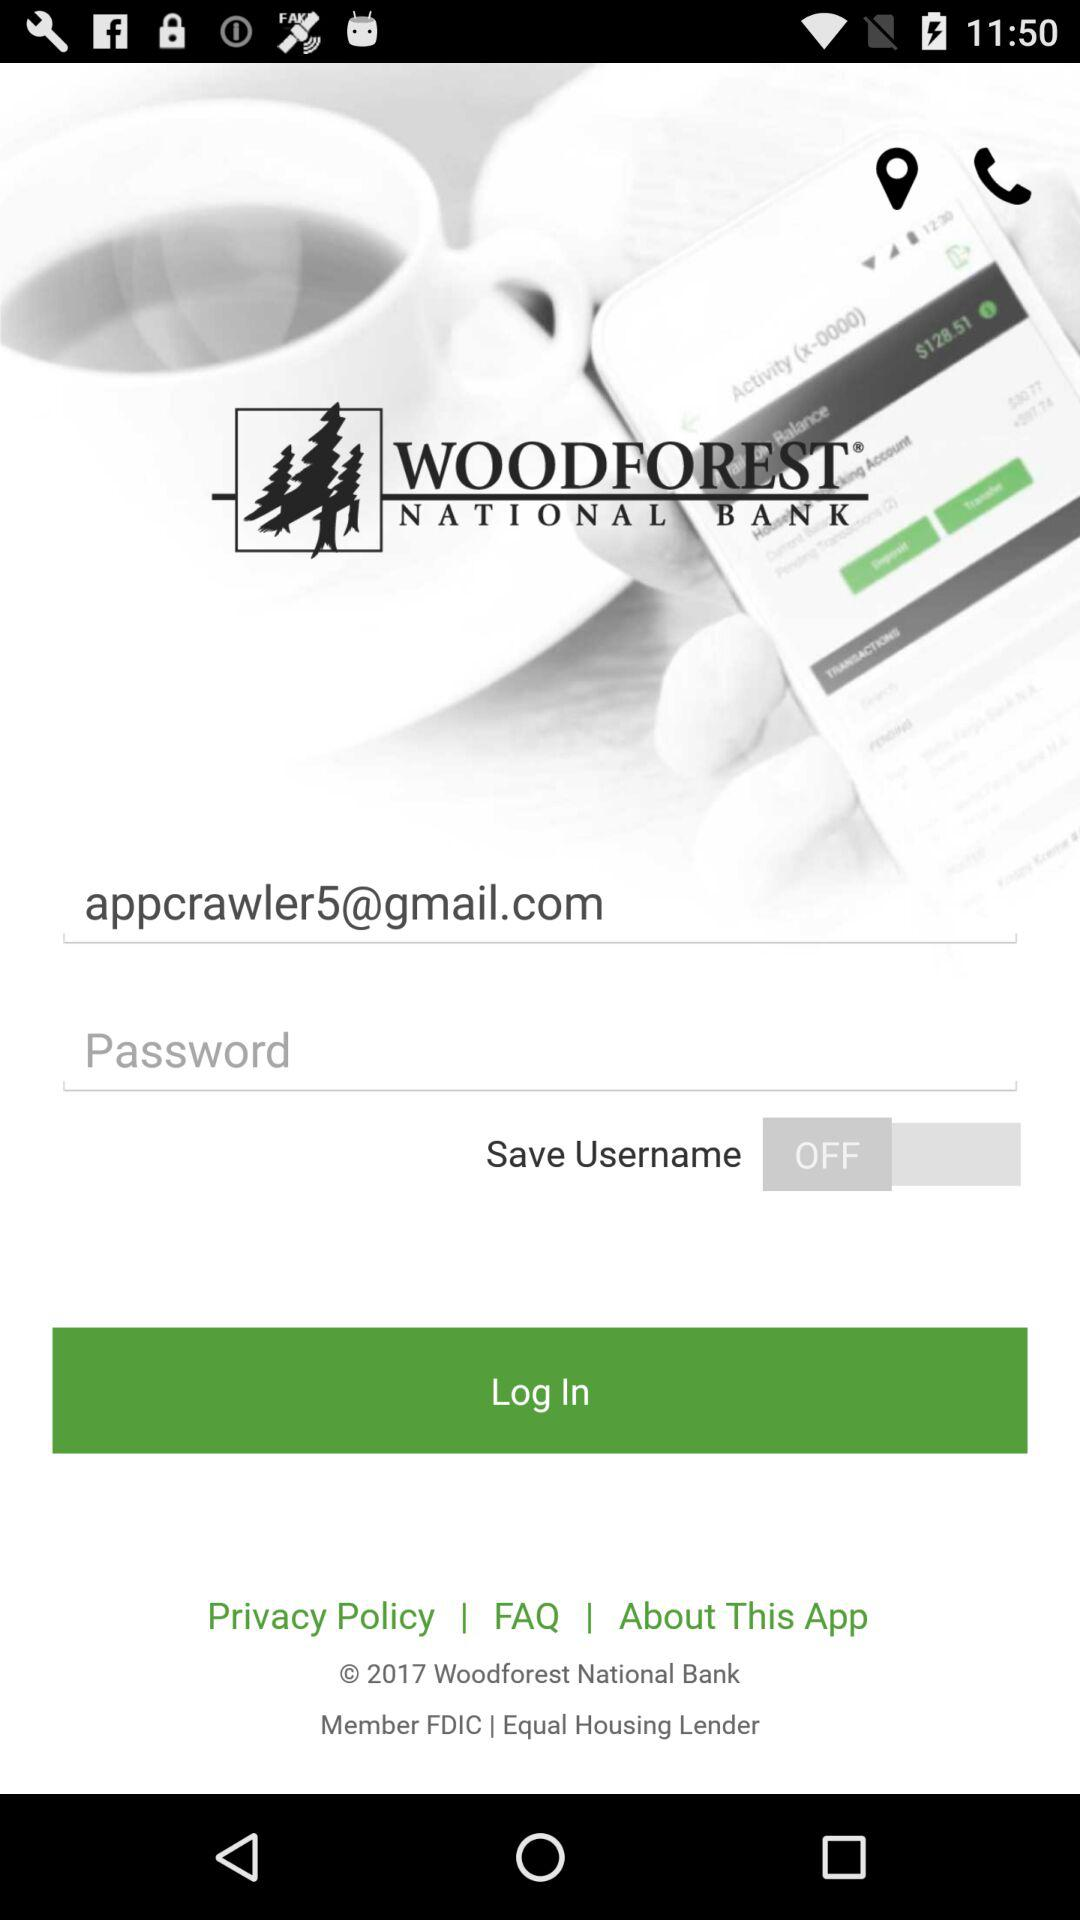What are the requirements to get a log in?
When the provided information is insufficient, respond with <no answer>. <no answer> 